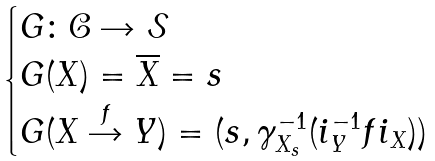Convert formula to latex. <formula><loc_0><loc_0><loc_500><loc_500>\begin{cases} G \colon \mathcal { C } \rightarrow \mathcal { S } \\ G ( X ) = \overline { X } = s \\ G ( X \stackrel { f } { \rightarrow } Y ) = ( s , \gamma _ { X _ { s } } ^ { - 1 } ( i _ { Y } ^ { - 1 } f i _ { X } ) ) \end{cases}</formula> 